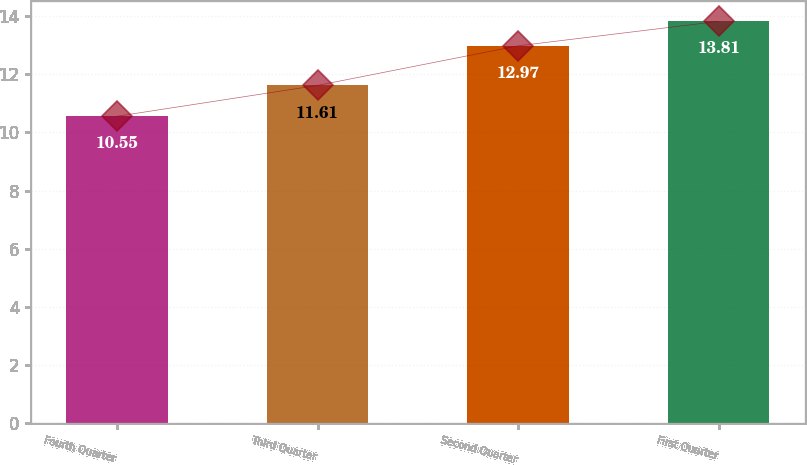<chart> <loc_0><loc_0><loc_500><loc_500><bar_chart><fcel>Fourth Quarter<fcel>Third Quarter<fcel>Second Quarter<fcel>First Quarter<nl><fcel>10.55<fcel>11.61<fcel>12.97<fcel>13.81<nl></chart> 